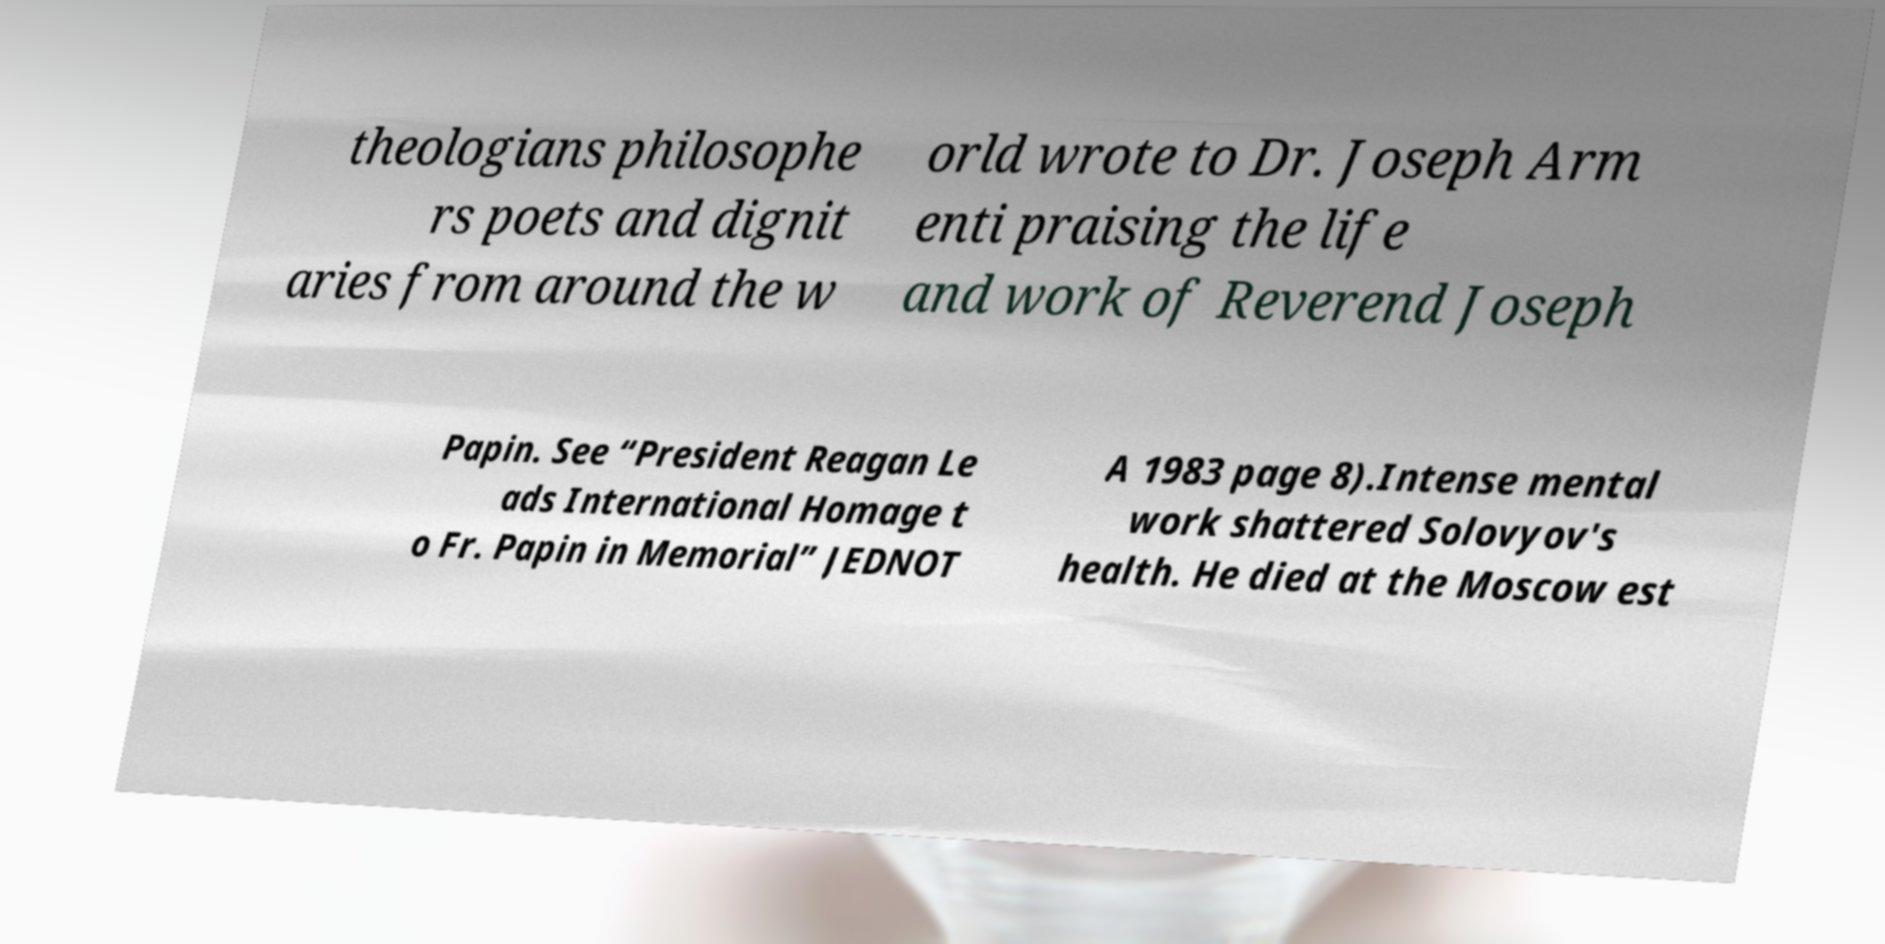What messages or text are displayed in this image? I need them in a readable, typed format. theologians philosophe rs poets and dignit aries from around the w orld wrote to Dr. Joseph Arm enti praising the life and work of Reverend Joseph Papin. See “President Reagan Le ads International Homage t o Fr. Papin in Memorial” JEDNOT A 1983 page 8).Intense mental work shattered Solovyov's health. He died at the Moscow est 